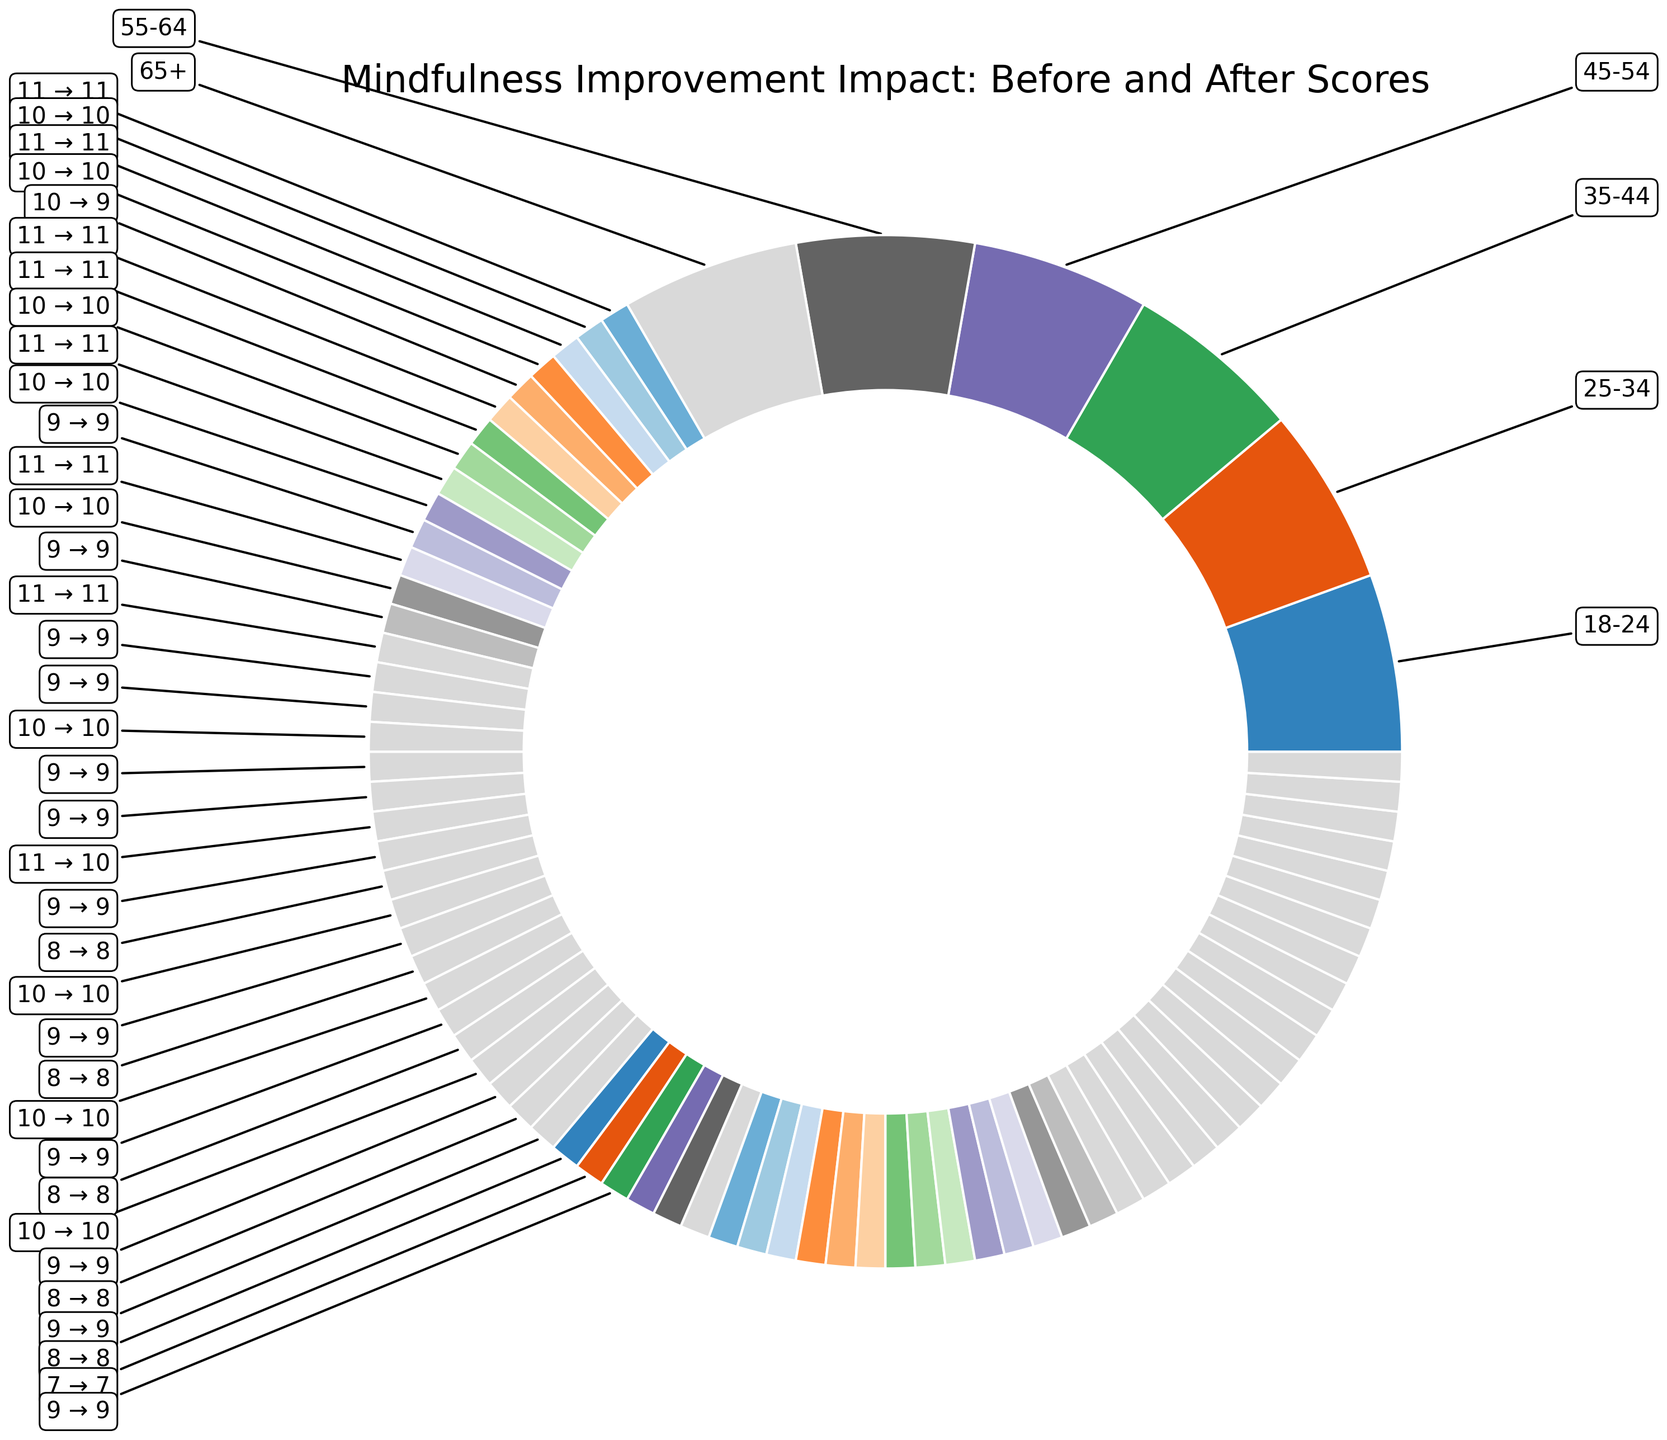What age group shows the highest average increase in mindfulness scores? To determine this, compare the average before and after scores for each age group. For example, for the age group 18-24, the differences for each category are 7, 8, 8, 9, 9, 11. Calculate the averages of these differences for all age groups and find the one with the highest value.
Answer: 25-34 Which gender has a higher average score improvement for daily usage time > 60 minutes in age group 35-44? Look at the scores under age group 35-44 and > 60 minutes. The improvements are 9 for males and 9 for females. Compare these two values.
Answer: Both have the same improvement What is the average improvement in mindfulness scores for females aged 55-64 using the program for 30-60 minutes daily? Sum the before and after scores for this category: Before (55), After (64). The difference is 64 - 55 = 9. There is only one data point for this group.
Answer: 9 Which age group and usage time combo has the lowest average before mindfulness score? Compare the average before scores across age groups and usage times. The lowest value in the entire dataset represents the group with the lowest average score.
Answer: 65+ with <30 minutes What is the highest improvement observed in any gender, age group, and usage time combination? Review the score differences for all combinations (e.g., male in 18-24 for <30 min is 7, etc.) and find the highest value among them.
Answer: Female in 25-34 with > 60 minutes (11 points) Compare the improvement in mindfulness scores for males and females aged 18-24 for 30-60 minutes daily usage. Review the improvements: Males in this category improved from 60 to 68 (8 points), whereas females improved from 64 to 73 (9 points). Compare these values.
Answer: Females have a higher improvement What is the total increase in mindfulness scores for males aged 45-54 across all usage times? Sum the differences for usage times <30 minutes, 30-60 minutes, and >60 minutes for males aged 45-54: (56-50)+(62-55)+(69-60) = 6+7+9 = 22.
Answer: 22 Which age group with daily usage time < 30 minutes for males has the highest after mindfulness score? Compare the after scores for males using the program <30 minutes across all age groups: 18-24 (65), 25-34 (62), 35-44 (59), 45-54 (56), 55-64 (54), 65+ (51). Identify the highest score.
Answer: 18-24 Is the average improvement in mindfulness scores higher for females or males for the age group 25-34? Calculate the average improvement for both genders: For Males: ((62-55)+(70-61)+(75-66))/3 = 7. For Females: ((66-58)+(72-63)+(78-67))/3 = 8. Compare these two averages.
Answer: Higher for females What is the impact of increasing daily usage time on mindfulness scores for the age group 18-24, combining both genders? Review the scores: <30 minutes Male (7), Female (8), 30-60 minutes Male (8), Female (9), >60 minutes Male (9), Female (11). Observe any trend as usage time increases.
Answer: Positive impact (Improvement increases with usage time) 